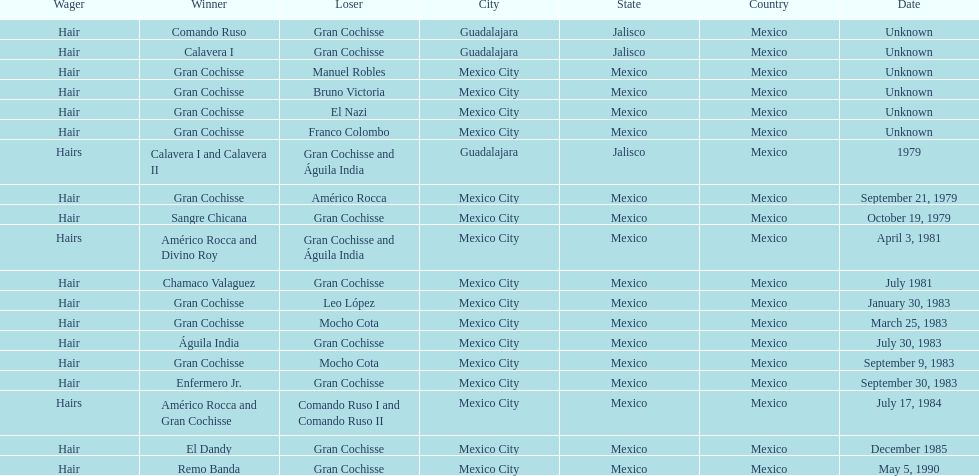When was gran chochisse first match that had a full date on record? September 21, 1979. 